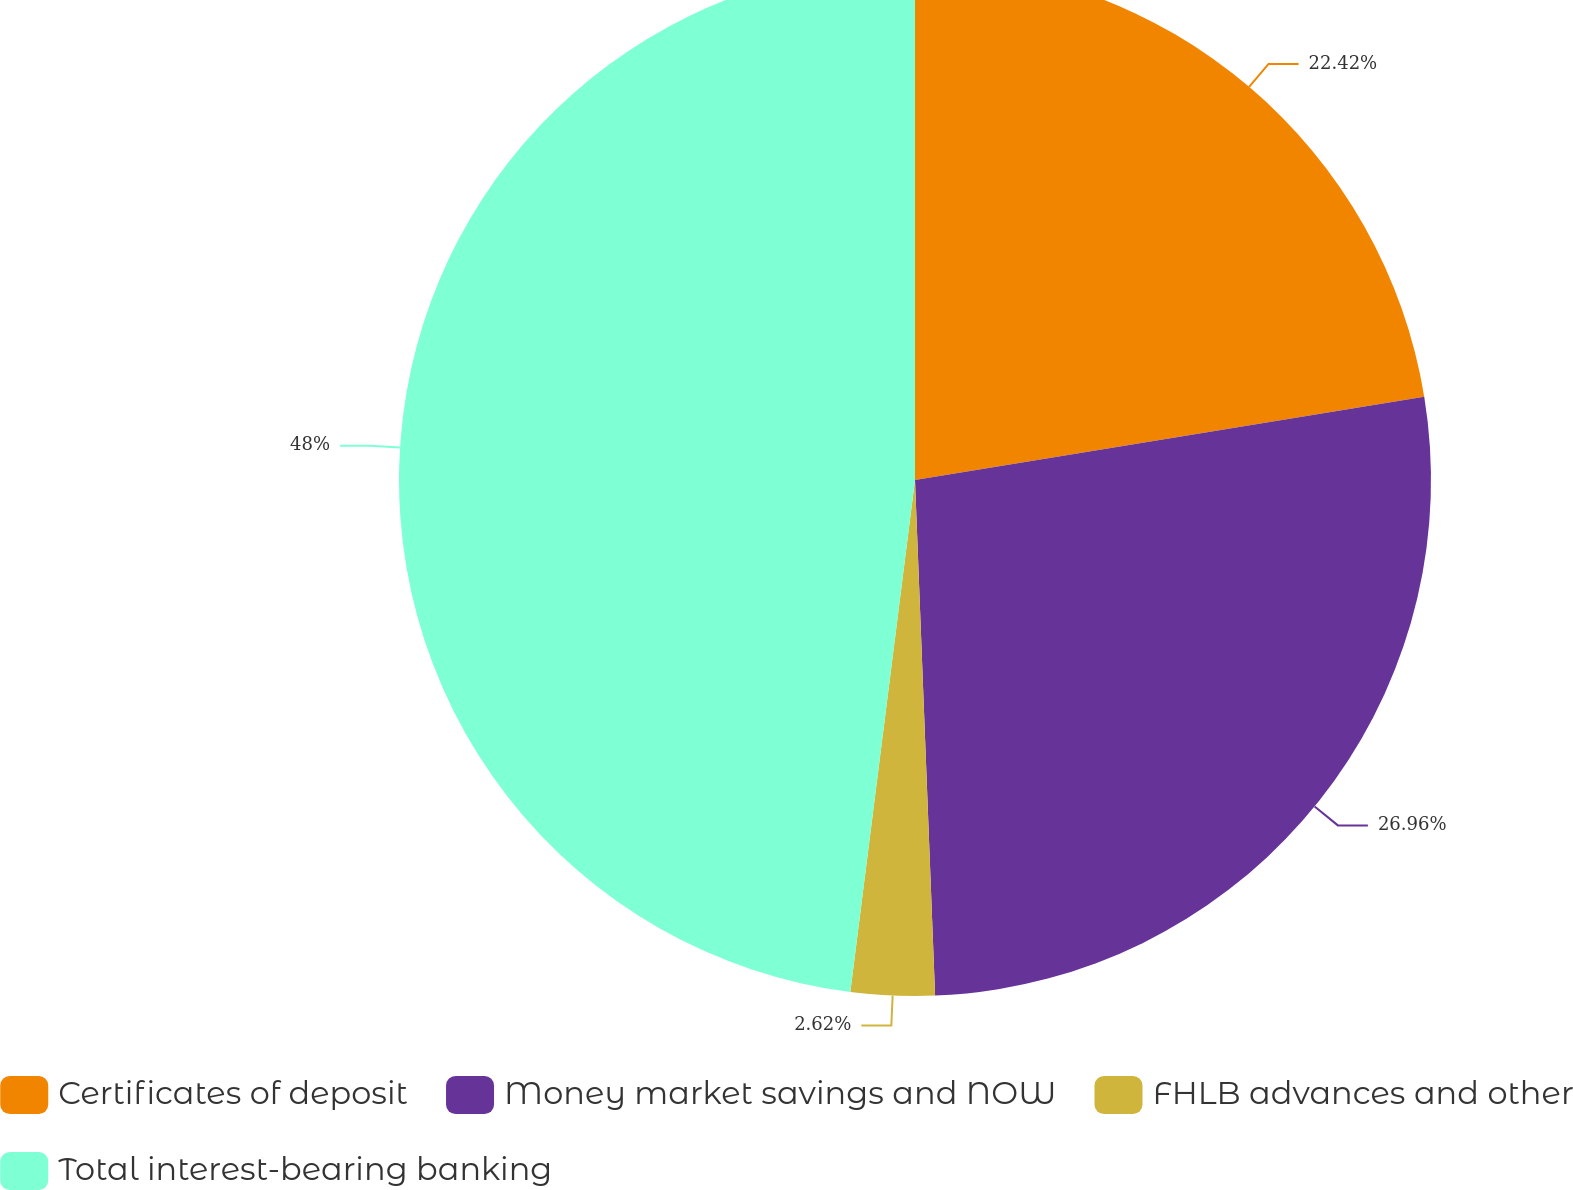Convert chart. <chart><loc_0><loc_0><loc_500><loc_500><pie_chart><fcel>Certificates of deposit<fcel>Money market savings and NOW<fcel>FHLB advances and other<fcel>Total interest-bearing banking<nl><fcel>22.42%<fcel>26.96%<fcel>2.62%<fcel>48.0%<nl></chart> 